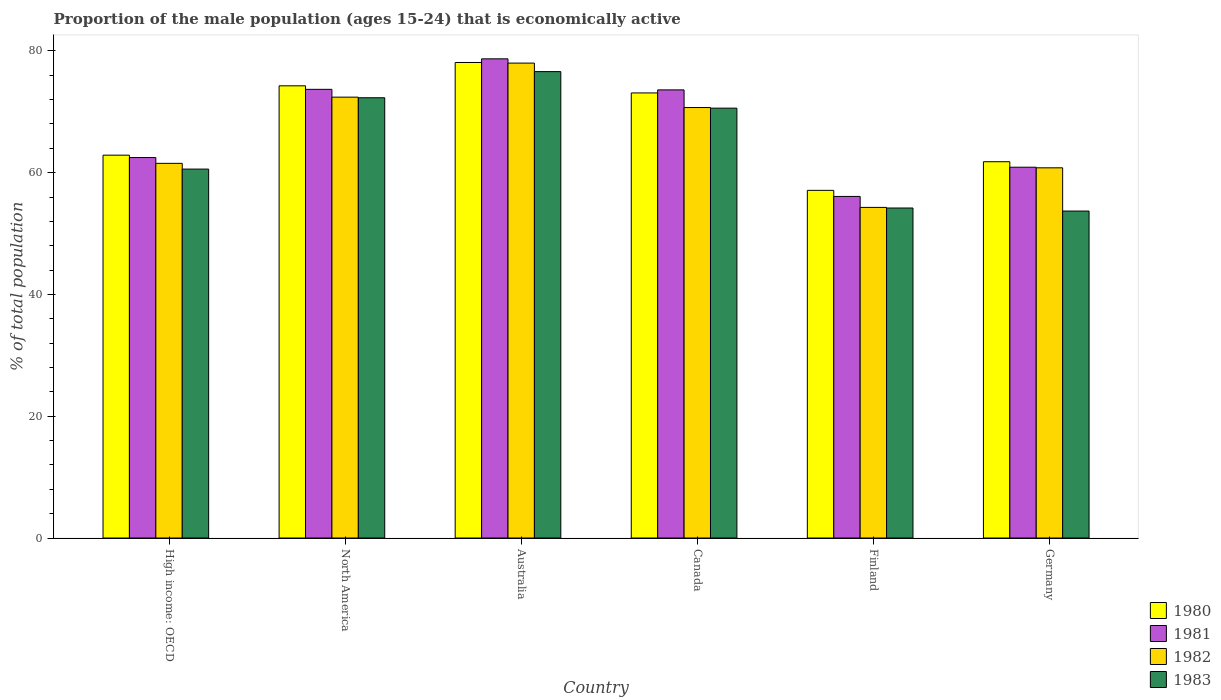Are the number of bars on each tick of the X-axis equal?
Keep it short and to the point. Yes. What is the label of the 3rd group of bars from the left?
Provide a succinct answer. Australia. In how many cases, is the number of bars for a given country not equal to the number of legend labels?
Provide a succinct answer. 0. What is the proportion of the male population that is economically active in 1981 in Finland?
Keep it short and to the point. 56.1. Across all countries, what is the maximum proportion of the male population that is economically active in 1981?
Keep it short and to the point. 78.7. Across all countries, what is the minimum proportion of the male population that is economically active in 1983?
Make the answer very short. 53.7. What is the total proportion of the male population that is economically active in 1982 in the graph?
Offer a very short reply. 397.74. What is the difference between the proportion of the male population that is economically active in 1980 in Canada and that in North America?
Ensure brevity in your answer.  -1.17. What is the difference between the proportion of the male population that is economically active in 1983 in Finland and the proportion of the male population that is economically active in 1980 in Germany?
Ensure brevity in your answer.  -7.6. What is the average proportion of the male population that is economically active in 1981 per country?
Your response must be concise. 67.58. What is the difference between the proportion of the male population that is economically active of/in 1982 and proportion of the male population that is economically active of/in 1983 in High income: OECD?
Offer a very short reply. 0.94. In how many countries, is the proportion of the male population that is economically active in 1981 greater than 24 %?
Provide a succinct answer. 6. What is the ratio of the proportion of the male population that is economically active in 1981 in Australia to that in Finland?
Offer a very short reply. 1.4. Is the difference between the proportion of the male population that is economically active in 1982 in Finland and North America greater than the difference between the proportion of the male population that is economically active in 1983 in Finland and North America?
Give a very brief answer. Yes. What is the difference between the highest and the second highest proportion of the male population that is economically active in 1982?
Your response must be concise. 1.71. What is the difference between the highest and the lowest proportion of the male population that is economically active in 1981?
Give a very brief answer. 22.6. In how many countries, is the proportion of the male population that is economically active in 1983 greater than the average proportion of the male population that is economically active in 1983 taken over all countries?
Provide a short and direct response. 3. Is the sum of the proportion of the male population that is economically active in 1983 in Canada and Germany greater than the maximum proportion of the male population that is economically active in 1982 across all countries?
Provide a short and direct response. Yes. Is it the case that in every country, the sum of the proportion of the male population that is economically active in 1982 and proportion of the male population that is economically active in 1980 is greater than the sum of proportion of the male population that is economically active in 1983 and proportion of the male population that is economically active in 1981?
Offer a very short reply. No. How many bars are there?
Provide a short and direct response. 24. Are all the bars in the graph horizontal?
Your answer should be very brief. No. How many countries are there in the graph?
Keep it short and to the point. 6. Are the values on the major ticks of Y-axis written in scientific E-notation?
Provide a succinct answer. No. Does the graph contain any zero values?
Give a very brief answer. No. Does the graph contain grids?
Your response must be concise. No. Where does the legend appear in the graph?
Provide a succinct answer. Bottom right. How many legend labels are there?
Give a very brief answer. 4. How are the legend labels stacked?
Provide a succinct answer. Vertical. What is the title of the graph?
Offer a very short reply. Proportion of the male population (ages 15-24) that is economically active. What is the label or title of the X-axis?
Your response must be concise. Country. What is the label or title of the Y-axis?
Your answer should be compact. % of total population. What is the % of total population of 1980 in High income: OECD?
Ensure brevity in your answer.  62.88. What is the % of total population in 1981 in High income: OECD?
Ensure brevity in your answer.  62.49. What is the % of total population in 1982 in High income: OECD?
Your response must be concise. 61.53. What is the % of total population of 1983 in High income: OECD?
Your response must be concise. 60.59. What is the % of total population in 1980 in North America?
Your answer should be very brief. 74.27. What is the % of total population of 1981 in North America?
Offer a very short reply. 73.69. What is the % of total population in 1982 in North America?
Ensure brevity in your answer.  72.41. What is the % of total population in 1983 in North America?
Your response must be concise. 72.31. What is the % of total population of 1980 in Australia?
Your answer should be compact. 78.1. What is the % of total population in 1981 in Australia?
Make the answer very short. 78.7. What is the % of total population in 1983 in Australia?
Offer a very short reply. 76.6. What is the % of total population of 1980 in Canada?
Give a very brief answer. 73.1. What is the % of total population in 1981 in Canada?
Provide a succinct answer. 73.6. What is the % of total population of 1982 in Canada?
Offer a terse response. 70.7. What is the % of total population of 1983 in Canada?
Keep it short and to the point. 70.6. What is the % of total population in 1980 in Finland?
Ensure brevity in your answer.  57.1. What is the % of total population in 1981 in Finland?
Give a very brief answer. 56.1. What is the % of total population in 1982 in Finland?
Keep it short and to the point. 54.3. What is the % of total population of 1983 in Finland?
Provide a short and direct response. 54.2. What is the % of total population of 1980 in Germany?
Provide a short and direct response. 61.8. What is the % of total population in 1981 in Germany?
Offer a very short reply. 60.9. What is the % of total population of 1982 in Germany?
Offer a very short reply. 60.8. What is the % of total population in 1983 in Germany?
Ensure brevity in your answer.  53.7. Across all countries, what is the maximum % of total population in 1980?
Keep it short and to the point. 78.1. Across all countries, what is the maximum % of total population of 1981?
Make the answer very short. 78.7. Across all countries, what is the maximum % of total population of 1983?
Give a very brief answer. 76.6. Across all countries, what is the minimum % of total population of 1980?
Offer a very short reply. 57.1. Across all countries, what is the minimum % of total population in 1981?
Your answer should be compact. 56.1. Across all countries, what is the minimum % of total population in 1982?
Give a very brief answer. 54.3. Across all countries, what is the minimum % of total population of 1983?
Provide a short and direct response. 53.7. What is the total % of total population of 1980 in the graph?
Your answer should be very brief. 407.25. What is the total % of total population of 1981 in the graph?
Your answer should be compact. 405.48. What is the total % of total population in 1982 in the graph?
Give a very brief answer. 397.74. What is the total % of total population of 1983 in the graph?
Provide a short and direct response. 388. What is the difference between the % of total population in 1980 in High income: OECD and that in North America?
Offer a very short reply. -11.39. What is the difference between the % of total population of 1981 in High income: OECD and that in North America?
Give a very brief answer. -11.2. What is the difference between the % of total population of 1982 in High income: OECD and that in North America?
Your answer should be compact. -10.87. What is the difference between the % of total population of 1983 in High income: OECD and that in North America?
Offer a very short reply. -11.71. What is the difference between the % of total population of 1980 in High income: OECD and that in Australia?
Your answer should be compact. -15.22. What is the difference between the % of total population of 1981 in High income: OECD and that in Australia?
Your response must be concise. -16.21. What is the difference between the % of total population of 1982 in High income: OECD and that in Australia?
Your answer should be very brief. -16.47. What is the difference between the % of total population of 1983 in High income: OECD and that in Australia?
Offer a very short reply. -16.01. What is the difference between the % of total population in 1980 in High income: OECD and that in Canada?
Offer a very short reply. -10.22. What is the difference between the % of total population of 1981 in High income: OECD and that in Canada?
Provide a succinct answer. -11.11. What is the difference between the % of total population of 1982 in High income: OECD and that in Canada?
Make the answer very short. -9.17. What is the difference between the % of total population in 1983 in High income: OECD and that in Canada?
Provide a succinct answer. -10.01. What is the difference between the % of total population in 1980 in High income: OECD and that in Finland?
Offer a very short reply. 5.78. What is the difference between the % of total population in 1981 in High income: OECD and that in Finland?
Offer a very short reply. 6.39. What is the difference between the % of total population of 1982 in High income: OECD and that in Finland?
Provide a short and direct response. 7.23. What is the difference between the % of total population in 1983 in High income: OECD and that in Finland?
Keep it short and to the point. 6.39. What is the difference between the % of total population of 1980 in High income: OECD and that in Germany?
Make the answer very short. 1.08. What is the difference between the % of total population of 1981 in High income: OECD and that in Germany?
Your answer should be compact. 1.59. What is the difference between the % of total population in 1982 in High income: OECD and that in Germany?
Provide a short and direct response. 0.73. What is the difference between the % of total population of 1983 in High income: OECD and that in Germany?
Ensure brevity in your answer.  6.89. What is the difference between the % of total population of 1980 in North America and that in Australia?
Make the answer very short. -3.83. What is the difference between the % of total population of 1981 in North America and that in Australia?
Offer a very short reply. -5.01. What is the difference between the % of total population of 1982 in North America and that in Australia?
Keep it short and to the point. -5.59. What is the difference between the % of total population of 1983 in North America and that in Australia?
Offer a very short reply. -4.29. What is the difference between the % of total population in 1980 in North America and that in Canada?
Keep it short and to the point. 1.17. What is the difference between the % of total population of 1981 in North America and that in Canada?
Keep it short and to the point. 0.09. What is the difference between the % of total population in 1982 in North America and that in Canada?
Provide a short and direct response. 1.71. What is the difference between the % of total population in 1983 in North America and that in Canada?
Provide a short and direct response. 1.71. What is the difference between the % of total population of 1980 in North America and that in Finland?
Ensure brevity in your answer.  17.17. What is the difference between the % of total population in 1981 in North America and that in Finland?
Ensure brevity in your answer.  17.59. What is the difference between the % of total population of 1982 in North America and that in Finland?
Your answer should be compact. 18.11. What is the difference between the % of total population in 1983 in North America and that in Finland?
Make the answer very short. 18.11. What is the difference between the % of total population of 1980 in North America and that in Germany?
Offer a terse response. 12.47. What is the difference between the % of total population of 1981 in North America and that in Germany?
Ensure brevity in your answer.  12.79. What is the difference between the % of total population of 1982 in North America and that in Germany?
Keep it short and to the point. 11.61. What is the difference between the % of total population of 1983 in North America and that in Germany?
Your response must be concise. 18.61. What is the difference between the % of total population of 1982 in Australia and that in Canada?
Ensure brevity in your answer.  7.3. What is the difference between the % of total population of 1980 in Australia and that in Finland?
Your answer should be very brief. 21. What is the difference between the % of total population in 1981 in Australia and that in Finland?
Provide a succinct answer. 22.6. What is the difference between the % of total population in 1982 in Australia and that in Finland?
Provide a succinct answer. 23.7. What is the difference between the % of total population in 1983 in Australia and that in Finland?
Provide a short and direct response. 22.4. What is the difference between the % of total population in 1980 in Australia and that in Germany?
Ensure brevity in your answer.  16.3. What is the difference between the % of total population in 1981 in Australia and that in Germany?
Provide a short and direct response. 17.8. What is the difference between the % of total population in 1983 in Australia and that in Germany?
Provide a short and direct response. 22.9. What is the difference between the % of total population of 1981 in Canada and that in Finland?
Provide a succinct answer. 17.5. What is the difference between the % of total population in 1981 in Canada and that in Germany?
Provide a succinct answer. 12.7. What is the difference between the % of total population of 1982 in Canada and that in Germany?
Make the answer very short. 9.9. What is the difference between the % of total population of 1983 in Canada and that in Germany?
Make the answer very short. 16.9. What is the difference between the % of total population in 1980 in Finland and that in Germany?
Ensure brevity in your answer.  -4.7. What is the difference between the % of total population of 1982 in Finland and that in Germany?
Make the answer very short. -6.5. What is the difference between the % of total population in 1983 in Finland and that in Germany?
Provide a short and direct response. 0.5. What is the difference between the % of total population in 1980 in High income: OECD and the % of total population in 1981 in North America?
Ensure brevity in your answer.  -10.81. What is the difference between the % of total population of 1980 in High income: OECD and the % of total population of 1982 in North America?
Make the answer very short. -9.53. What is the difference between the % of total population in 1980 in High income: OECD and the % of total population in 1983 in North America?
Provide a short and direct response. -9.43. What is the difference between the % of total population of 1981 in High income: OECD and the % of total population of 1982 in North America?
Give a very brief answer. -9.92. What is the difference between the % of total population of 1981 in High income: OECD and the % of total population of 1983 in North America?
Ensure brevity in your answer.  -9.82. What is the difference between the % of total population of 1982 in High income: OECD and the % of total population of 1983 in North America?
Your answer should be very brief. -10.77. What is the difference between the % of total population of 1980 in High income: OECD and the % of total population of 1981 in Australia?
Offer a terse response. -15.82. What is the difference between the % of total population in 1980 in High income: OECD and the % of total population in 1982 in Australia?
Your response must be concise. -15.12. What is the difference between the % of total population of 1980 in High income: OECD and the % of total population of 1983 in Australia?
Offer a terse response. -13.72. What is the difference between the % of total population in 1981 in High income: OECD and the % of total population in 1982 in Australia?
Offer a very short reply. -15.51. What is the difference between the % of total population of 1981 in High income: OECD and the % of total population of 1983 in Australia?
Your answer should be very brief. -14.11. What is the difference between the % of total population in 1982 in High income: OECD and the % of total population in 1983 in Australia?
Provide a short and direct response. -15.07. What is the difference between the % of total population of 1980 in High income: OECD and the % of total population of 1981 in Canada?
Your response must be concise. -10.72. What is the difference between the % of total population of 1980 in High income: OECD and the % of total population of 1982 in Canada?
Provide a succinct answer. -7.82. What is the difference between the % of total population in 1980 in High income: OECD and the % of total population in 1983 in Canada?
Keep it short and to the point. -7.72. What is the difference between the % of total population in 1981 in High income: OECD and the % of total population in 1982 in Canada?
Provide a succinct answer. -8.21. What is the difference between the % of total population in 1981 in High income: OECD and the % of total population in 1983 in Canada?
Your answer should be compact. -8.11. What is the difference between the % of total population of 1982 in High income: OECD and the % of total population of 1983 in Canada?
Keep it short and to the point. -9.07. What is the difference between the % of total population in 1980 in High income: OECD and the % of total population in 1981 in Finland?
Your answer should be very brief. 6.78. What is the difference between the % of total population in 1980 in High income: OECD and the % of total population in 1982 in Finland?
Keep it short and to the point. 8.58. What is the difference between the % of total population in 1980 in High income: OECD and the % of total population in 1983 in Finland?
Give a very brief answer. 8.68. What is the difference between the % of total population in 1981 in High income: OECD and the % of total population in 1982 in Finland?
Make the answer very short. 8.19. What is the difference between the % of total population in 1981 in High income: OECD and the % of total population in 1983 in Finland?
Offer a very short reply. 8.29. What is the difference between the % of total population in 1982 in High income: OECD and the % of total population in 1983 in Finland?
Offer a very short reply. 7.33. What is the difference between the % of total population of 1980 in High income: OECD and the % of total population of 1981 in Germany?
Your response must be concise. 1.98. What is the difference between the % of total population of 1980 in High income: OECD and the % of total population of 1982 in Germany?
Your response must be concise. 2.08. What is the difference between the % of total population of 1980 in High income: OECD and the % of total population of 1983 in Germany?
Provide a succinct answer. 9.18. What is the difference between the % of total population in 1981 in High income: OECD and the % of total population in 1982 in Germany?
Make the answer very short. 1.69. What is the difference between the % of total population of 1981 in High income: OECD and the % of total population of 1983 in Germany?
Ensure brevity in your answer.  8.79. What is the difference between the % of total population of 1982 in High income: OECD and the % of total population of 1983 in Germany?
Offer a very short reply. 7.83. What is the difference between the % of total population of 1980 in North America and the % of total population of 1981 in Australia?
Provide a succinct answer. -4.43. What is the difference between the % of total population in 1980 in North America and the % of total population in 1982 in Australia?
Provide a short and direct response. -3.73. What is the difference between the % of total population of 1980 in North America and the % of total population of 1983 in Australia?
Provide a succinct answer. -2.33. What is the difference between the % of total population in 1981 in North America and the % of total population in 1982 in Australia?
Give a very brief answer. -4.31. What is the difference between the % of total population of 1981 in North America and the % of total population of 1983 in Australia?
Your answer should be compact. -2.91. What is the difference between the % of total population in 1982 in North America and the % of total population in 1983 in Australia?
Provide a short and direct response. -4.19. What is the difference between the % of total population of 1980 in North America and the % of total population of 1981 in Canada?
Keep it short and to the point. 0.67. What is the difference between the % of total population in 1980 in North America and the % of total population in 1982 in Canada?
Your answer should be very brief. 3.57. What is the difference between the % of total population of 1980 in North America and the % of total population of 1983 in Canada?
Your answer should be compact. 3.67. What is the difference between the % of total population in 1981 in North America and the % of total population in 1982 in Canada?
Provide a succinct answer. 2.99. What is the difference between the % of total population of 1981 in North America and the % of total population of 1983 in Canada?
Your response must be concise. 3.09. What is the difference between the % of total population of 1982 in North America and the % of total population of 1983 in Canada?
Offer a very short reply. 1.81. What is the difference between the % of total population of 1980 in North America and the % of total population of 1981 in Finland?
Keep it short and to the point. 18.17. What is the difference between the % of total population in 1980 in North America and the % of total population in 1982 in Finland?
Give a very brief answer. 19.97. What is the difference between the % of total population of 1980 in North America and the % of total population of 1983 in Finland?
Your response must be concise. 20.07. What is the difference between the % of total population in 1981 in North America and the % of total population in 1982 in Finland?
Your response must be concise. 19.39. What is the difference between the % of total population in 1981 in North America and the % of total population in 1983 in Finland?
Keep it short and to the point. 19.49. What is the difference between the % of total population in 1982 in North America and the % of total population in 1983 in Finland?
Provide a short and direct response. 18.21. What is the difference between the % of total population of 1980 in North America and the % of total population of 1981 in Germany?
Offer a terse response. 13.37. What is the difference between the % of total population in 1980 in North America and the % of total population in 1982 in Germany?
Ensure brevity in your answer.  13.47. What is the difference between the % of total population of 1980 in North America and the % of total population of 1983 in Germany?
Your answer should be compact. 20.57. What is the difference between the % of total population in 1981 in North America and the % of total population in 1982 in Germany?
Provide a short and direct response. 12.89. What is the difference between the % of total population in 1981 in North America and the % of total population in 1983 in Germany?
Give a very brief answer. 19.99. What is the difference between the % of total population in 1982 in North America and the % of total population in 1983 in Germany?
Provide a succinct answer. 18.71. What is the difference between the % of total population in 1980 in Australia and the % of total population in 1981 in Canada?
Your response must be concise. 4.5. What is the difference between the % of total population in 1981 in Australia and the % of total population in 1982 in Canada?
Give a very brief answer. 8. What is the difference between the % of total population in 1980 in Australia and the % of total population in 1982 in Finland?
Ensure brevity in your answer.  23.8. What is the difference between the % of total population of 1980 in Australia and the % of total population of 1983 in Finland?
Keep it short and to the point. 23.9. What is the difference between the % of total population in 1981 in Australia and the % of total population in 1982 in Finland?
Offer a very short reply. 24.4. What is the difference between the % of total population in 1982 in Australia and the % of total population in 1983 in Finland?
Provide a short and direct response. 23.8. What is the difference between the % of total population of 1980 in Australia and the % of total population of 1981 in Germany?
Your response must be concise. 17.2. What is the difference between the % of total population in 1980 in Australia and the % of total population in 1983 in Germany?
Provide a short and direct response. 24.4. What is the difference between the % of total population in 1981 in Australia and the % of total population in 1982 in Germany?
Make the answer very short. 17.9. What is the difference between the % of total population in 1981 in Australia and the % of total population in 1983 in Germany?
Keep it short and to the point. 25. What is the difference between the % of total population in 1982 in Australia and the % of total population in 1983 in Germany?
Your response must be concise. 24.3. What is the difference between the % of total population of 1980 in Canada and the % of total population of 1981 in Finland?
Provide a succinct answer. 17. What is the difference between the % of total population in 1980 in Canada and the % of total population in 1983 in Finland?
Keep it short and to the point. 18.9. What is the difference between the % of total population in 1981 in Canada and the % of total population in 1982 in Finland?
Make the answer very short. 19.3. What is the difference between the % of total population of 1981 in Canada and the % of total population of 1983 in Finland?
Ensure brevity in your answer.  19.4. What is the difference between the % of total population in 1980 in Canada and the % of total population in 1982 in Germany?
Provide a short and direct response. 12.3. What is the difference between the % of total population in 1981 in Canada and the % of total population in 1983 in Germany?
Make the answer very short. 19.9. What is the difference between the % of total population of 1981 in Finland and the % of total population of 1982 in Germany?
Ensure brevity in your answer.  -4.7. What is the average % of total population in 1980 per country?
Give a very brief answer. 67.87. What is the average % of total population in 1981 per country?
Keep it short and to the point. 67.58. What is the average % of total population of 1982 per country?
Provide a short and direct response. 66.29. What is the average % of total population in 1983 per country?
Your answer should be compact. 64.67. What is the difference between the % of total population in 1980 and % of total population in 1981 in High income: OECD?
Offer a terse response. 0.39. What is the difference between the % of total population in 1980 and % of total population in 1982 in High income: OECD?
Your answer should be compact. 1.34. What is the difference between the % of total population of 1980 and % of total population of 1983 in High income: OECD?
Provide a succinct answer. 2.29. What is the difference between the % of total population in 1981 and % of total population in 1983 in High income: OECD?
Give a very brief answer. 1.89. What is the difference between the % of total population of 1982 and % of total population of 1983 in High income: OECD?
Give a very brief answer. 0.94. What is the difference between the % of total population in 1980 and % of total population in 1981 in North America?
Keep it short and to the point. 0.58. What is the difference between the % of total population in 1980 and % of total population in 1982 in North America?
Make the answer very short. 1.86. What is the difference between the % of total population in 1980 and % of total population in 1983 in North America?
Make the answer very short. 1.96. What is the difference between the % of total population of 1981 and % of total population of 1982 in North America?
Your answer should be compact. 1.28. What is the difference between the % of total population of 1981 and % of total population of 1983 in North America?
Your response must be concise. 1.38. What is the difference between the % of total population in 1982 and % of total population in 1983 in North America?
Offer a very short reply. 0.1. What is the difference between the % of total population of 1980 and % of total population of 1981 in Australia?
Your answer should be compact. -0.6. What is the difference between the % of total population of 1980 and % of total population of 1982 in Australia?
Offer a terse response. 0.1. What is the difference between the % of total population in 1981 and % of total population in 1983 in Australia?
Offer a terse response. 2.1. What is the difference between the % of total population in 1982 and % of total population in 1983 in Australia?
Ensure brevity in your answer.  1.4. What is the difference between the % of total population in 1980 and % of total population in 1983 in Canada?
Your answer should be very brief. 2.5. What is the difference between the % of total population in 1981 and % of total population in 1982 in Canada?
Give a very brief answer. 2.9. What is the difference between the % of total population in 1982 and % of total population in 1983 in Canada?
Your response must be concise. 0.1. What is the difference between the % of total population in 1980 and % of total population in 1981 in Finland?
Ensure brevity in your answer.  1. What is the difference between the % of total population in 1980 and % of total population in 1983 in Finland?
Provide a short and direct response. 2.9. What is the difference between the % of total population of 1982 and % of total population of 1983 in Finland?
Your response must be concise. 0.1. What is the difference between the % of total population in 1980 and % of total population in 1981 in Germany?
Make the answer very short. 0.9. What is the difference between the % of total population of 1980 and % of total population of 1983 in Germany?
Ensure brevity in your answer.  8.1. What is the difference between the % of total population in 1981 and % of total population in 1982 in Germany?
Provide a short and direct response. 0.1. What is the difference between the % of total population of 1981 and % of total population of 1983 in Germany?
Provide a succinct answer. 7.2. What is the ratio of the % of total population in 1980 in High income: OECD to that in North America?
Make the answer very short. 0.85. What is the ratio of the % of total population in 1981 in High income: OECD to that in North America?
Provide a short and direct response. 0.85. What is the ratio of the % of total population in 1982 in High income: OECD to that in North America?
Your answer should be compact. 0.85. What is the ratio of the % of total population in 1983 in High income: OECD to that in North America?
Your response must be concise. 0.84. What is the ratio of the % of total population of 1980 in High income: OECD to that in Australia?
Ensure brevity in your answer.  0.81. What is the ratio of the % of total population in 1981 in High income: OECD to that in Australia?
Provide a succinct answer. 0.79. What is the ratio of the % of total population in 1982 in High income: OECD to that in Australia?
Make the answer very short. 0.79. What is the ratio of the % of total population of 1983 in High income: OECD to that in Australia?
Ensure brevity in your answer.  0.79. What is the ratio of the % of total population of 1980 in High income: OECD to that in Canada?
Offer a very short reply. 0.86. What is the ratio of the % of total population in 1981 in High income: OECD to that in Canada?
Keep it short and to the point. 0.85. What is the ratio of the % of total population in 1982 in High income: OECD to that in Canada?
Your answer should be very brief. 0.87. What is the ratio of the % of total population in 1983 in High income: OECD to that in Canada?
Provide a succinct answer. 0.86. What is the ratio of the % of total population of 1980 in High income: OECD to that in Finland?
Your response must be concise. 1.1. What is the ratio of the % of total population in 1981 in High income: OECD to that in Finland?
Offer a very short reply. 1.11. What is the ratio of the % of total population in 1982 in High income: OECD to that in Finland?
Offer a terse response. 1.13. What is the ratio of the % of total population in 1983 in High income: OECD to that in Finland?
Your answer should be very brief. 1.12. What is the ratio of the % of total population in 1980 in High income: OECD to that in Germany?
Keep it short and to the point. 1.02. What is the ratio of the % of total population in 1981 in High income: OECD to that in Germany?
Give a very brief answer. 1.03. What is the ratio of the % of total population in 1982 in High income: OECD to that in Germany?
Your answer should be very brief. 1.01. What is the ratio of the % of total population in 1983 in High income: OECD to that in Germany?
Ensure brevity in your answer.  1.13. What is the ratio of the % of total population of 1980 in North America to that in Australia?
Provide a succinct answer. 0.95. What is the ratio of the % of total population in 1981 in North America to that in Australia?
Offer a terse response. 0.94. What is the ratio of the % of total population in 1982 in North America to that in Australia?
Your answer should be very brief. 0.93. What is the ratio of the % of total population of 1983 in North America to that in Australia?
Make the answer very short. 0.94. What is the ratio of the % of total population of 1982 in North America to that in Canada?
Provide a succinct answer. 1.02. What is the ratio of the % of total population of 1983 in North America to that in Canada?
Your answer should be very brief. 1.02. What is the ratio of the % of total population in 1980 in North America to that in Finland?
Make the answer very short. 1.3. What is the ratio of the % of total population in 1981 in North America to that in Finland?
Keep it short and to the point. 1.31. What is the ratio of the % of total population of 1982 in North America to that in Finland?
Ensure brevity in your answer.  1.33. What is the ratio of the % of total population in 1983 in North America to that in Finland?
Ensure brevity in your answer.  1.33. What is the ratio of the % of total population of 1980 in North America to that in Germany?
Your answer should be very brief. 1.2. What is the ratio of the % of total population of 1981 in North America to that in Germany?
Your response must be concise. 1.21. What is the ratio of the % of total population in 1982 in North America to that in Germany?
Your response must be concise. 1.19. What is the ratio of the % of total population of 1983 in North America to that in Germany?
Your answer should be very brief. 1.35. What is the ratio of the % of total population of 1980 in Australia to that in Canada?
Keep it short and to the point. 1.07. What is the ratio of the % of total population in 1981 in Australia to that in Canada?
Ensure brevity in your answer.  1.07. What is the ratio of the % of total population in 1982 in Australia to that in Canada?
Provide a short and direct response. 1.1. What is the ratio of the % of total population in 1983 in Australia to that in Canada?
Ensure brevity in your answer.  1.08. What is the ratio of the % of total population of 1980 in Australia to that in Finland?
Provide a short and direct response. 1.37. What is the ratio of the % of total population in 1981 in Australia to that in Finland?
Your response must be concise. 1.4. What is the ratio of the % of total population in 1982 in Australia to that in Finland?
Give a very brief answer. 1.44. What is the ratio of the % of total population of 1983 in Australia to that in Finland?
Provide a succinct answer. 1.41. What is the ratio of the % of total population in 1980 in Australia to that in Germany?
Make the answer very short. 1.26. What is the ratio of the % of total population in 1981 in Australia to that in Germany?
Give a very brief answer. 1.29. What is the ratio of the % of total population of 1982 in Australia to that in Germany?
Your answer should be very brief. 1.28. What is the ratio of the % of total population in 1983 in Australia to that in Germany?
Ensure brevity in your answer.  1.43. What is the ratio of the % of total population of 1980 in Canada to that in Finland?
Make the answer very short. 1.28. What is the ratio of the % of total population in 1981 in Canada to that in Finland?
Offer a very short reply. 1.31. What is the ratio of the % of total population of 1982 in Canada to that in Finland?
Your response must be concise. 1.3. What is the ratio of the % of total population in 1983 in Canada to that in Finland?
Ensure brevity in your answer.  1.3. What is the ratio of the % of total population in 1980 in Canada to that in Germany?
Your response must be concise. 1.18. What is the ratio of the % of total population of 1981 in Canada to that in Germany?
Provide a short and direct response. 1.21. What is the ratio of the % of total population in 1982 in Canada to that in Germany?
Offer a terse response. 1.16. What is the ratio of the % of total population in 1983 in Canada to that in Germany?
Your answer should be compact. 1.31. What is the ratio of the % of total population of 1980 in Finland to that in Germany?
Keep it short and to the point. 0.92. What is the ratio of the % of total population in 1981 in Finland to that in Germany?
Ensure brevity in your answer.  0.92. What is the ratio of the % of total population of 1982 in Finland to that in Germany?
Provide a succinct answer. 0.89. What is the ratio of the % of total population of 1983 in Finland to that in Germany?
Give a very brief answer. 1.01. What is the difference between the highest and the second highest % of total population in 1980?
Your answer should be very brief. 3.83. What is the difference between the highest and the second highest % of total population of 1981?
Give a very brief answer. 5.01. What is the difference between the highest and the second highest % of total population in 1982?
Your answer should be compact. 5.59. What is the difference between the highest and the second highest % of total population in 1983?
Keep it short and to the point. 4.29. What is the difference between the highest and the lowest % of total population in 1981?
Provide a short and direct response. 22.6. What is the difference between the highest and the lowest % of total population in 1982?
Give a very brief answer. 23.7. What is the difference between the highest and the lowest % of total population in 1983?
Your answer should be very brief. 22.9. 